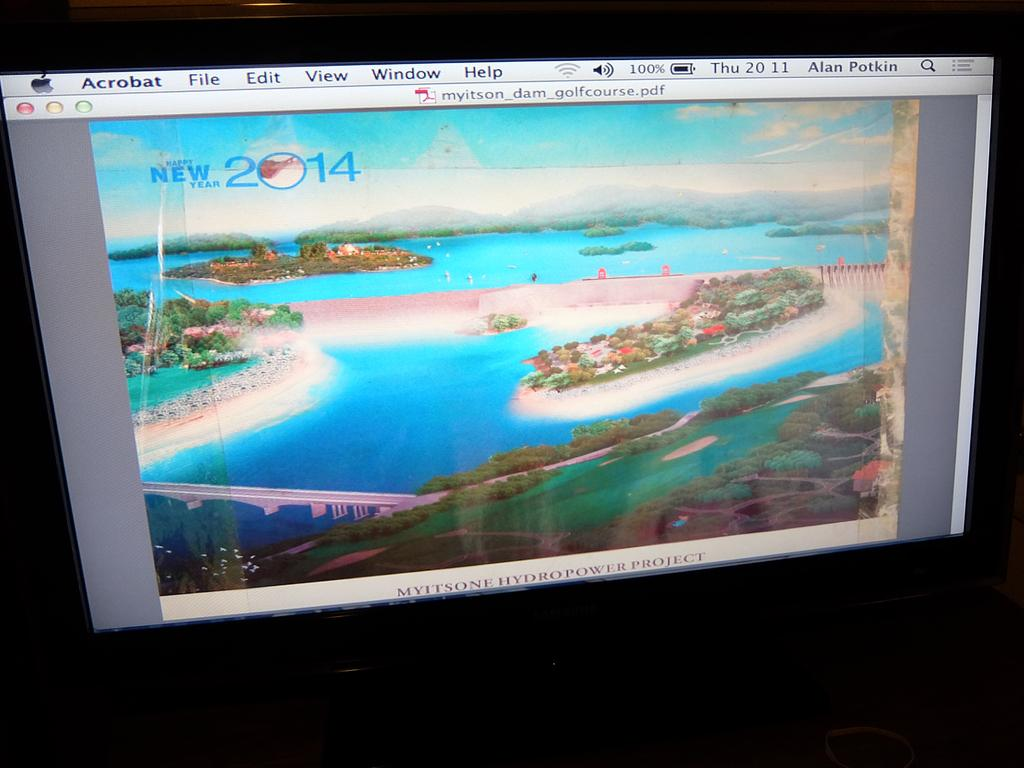<image>
Create a compact narrative representing the image presented. A computer screen says happy new year 2014 and shows a beach. 